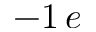<formula> <loc_0><loc_0><loc_500><loc_500>- 1 \, e</formula> 